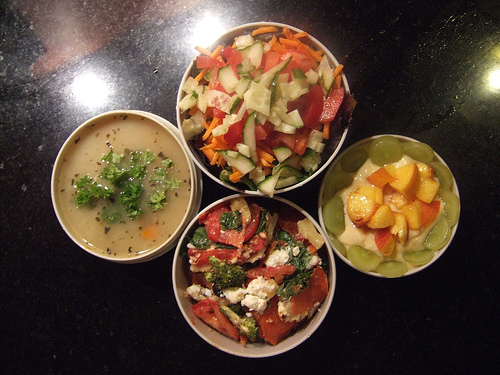<image>
Is the tomato to the left of the tomato? No. The tomato is not to the left of the tomato. From this viewpoint, they have a different horizontal relationship. 